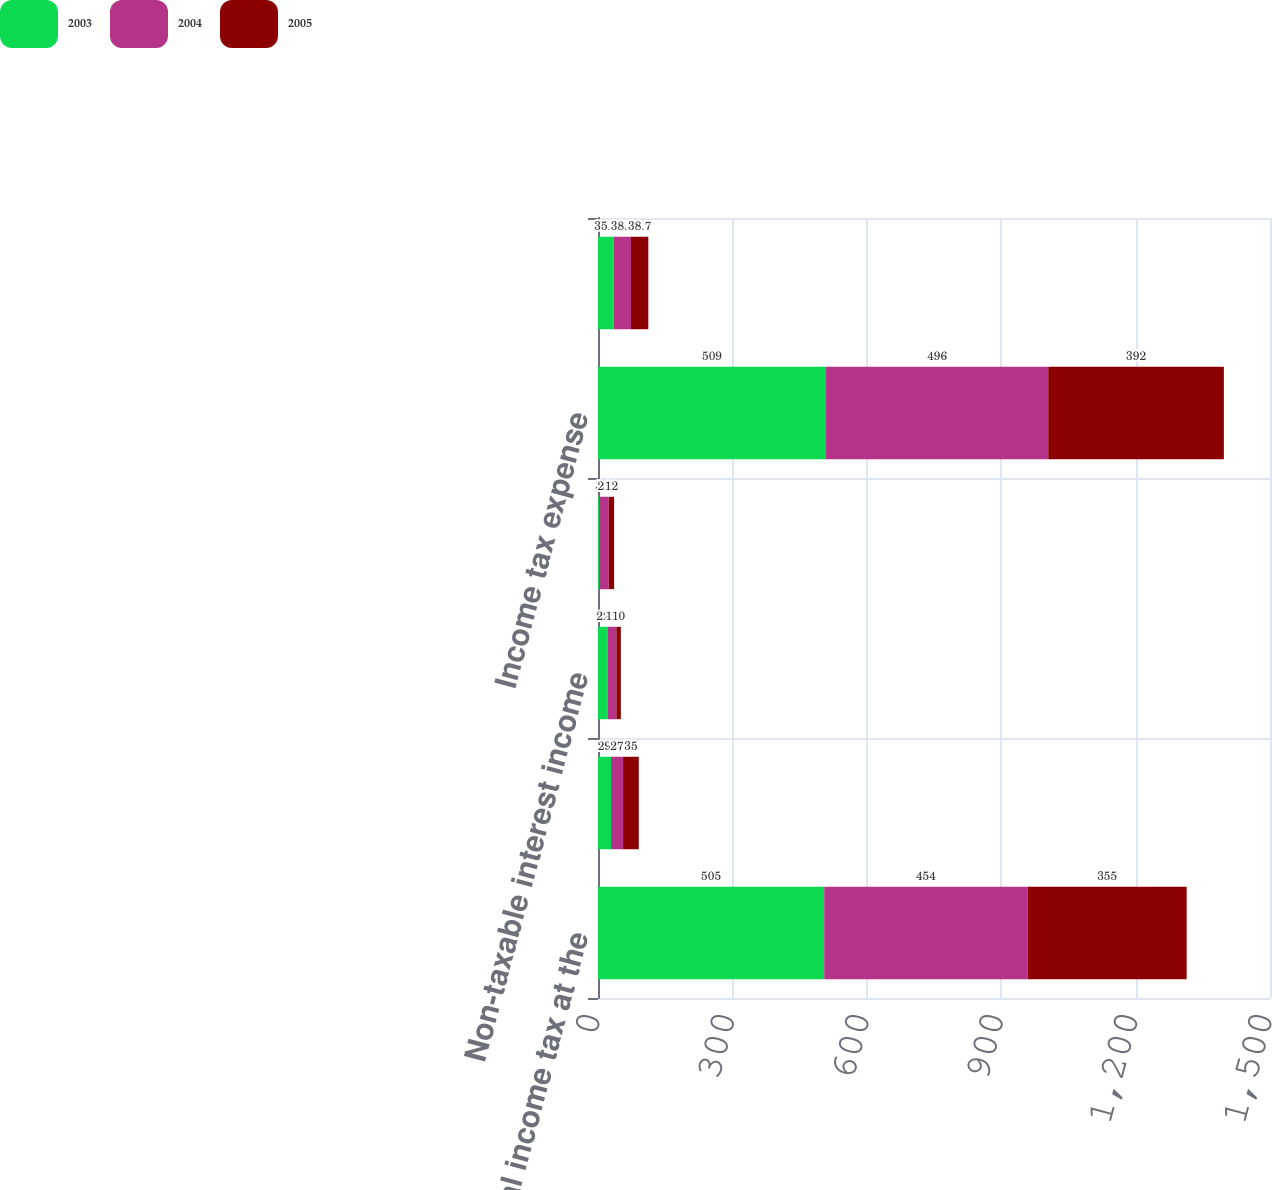Convert chart to OTSL. <chart><loc_0><loc_0><loc_500><loc_500><stacked_bar_chart><ecel><fcel>Federal income tax at the<fcel>State income taxes net of<fcel>Non-taxable interest income<fcel>Other<fcel>Income tax expense<fcel>Effective income tax rate<nl><fcel>2003<fcel>505<fcel>29<fcel>22<fcel>3<fcel>509<fcel>35.3<nl><fcel>2004<fcel>454<fcel>27<fcel>19<fcel>21<fcel>496<fcel>38.3<nl><fcel>2005<fcel>355<fcel>35<fcel>10<fcel>12<fcel>392<fcel>38.7<nl></chart> 